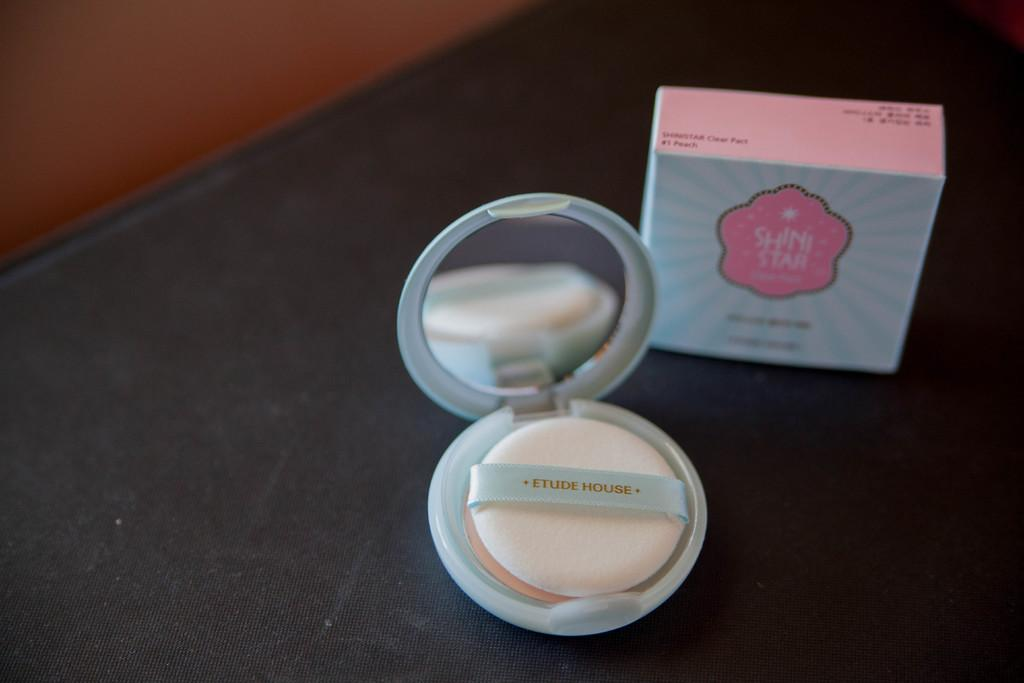Provide a one-sentence caption for the provided image. The makeup is labeled Etude House on the table. 